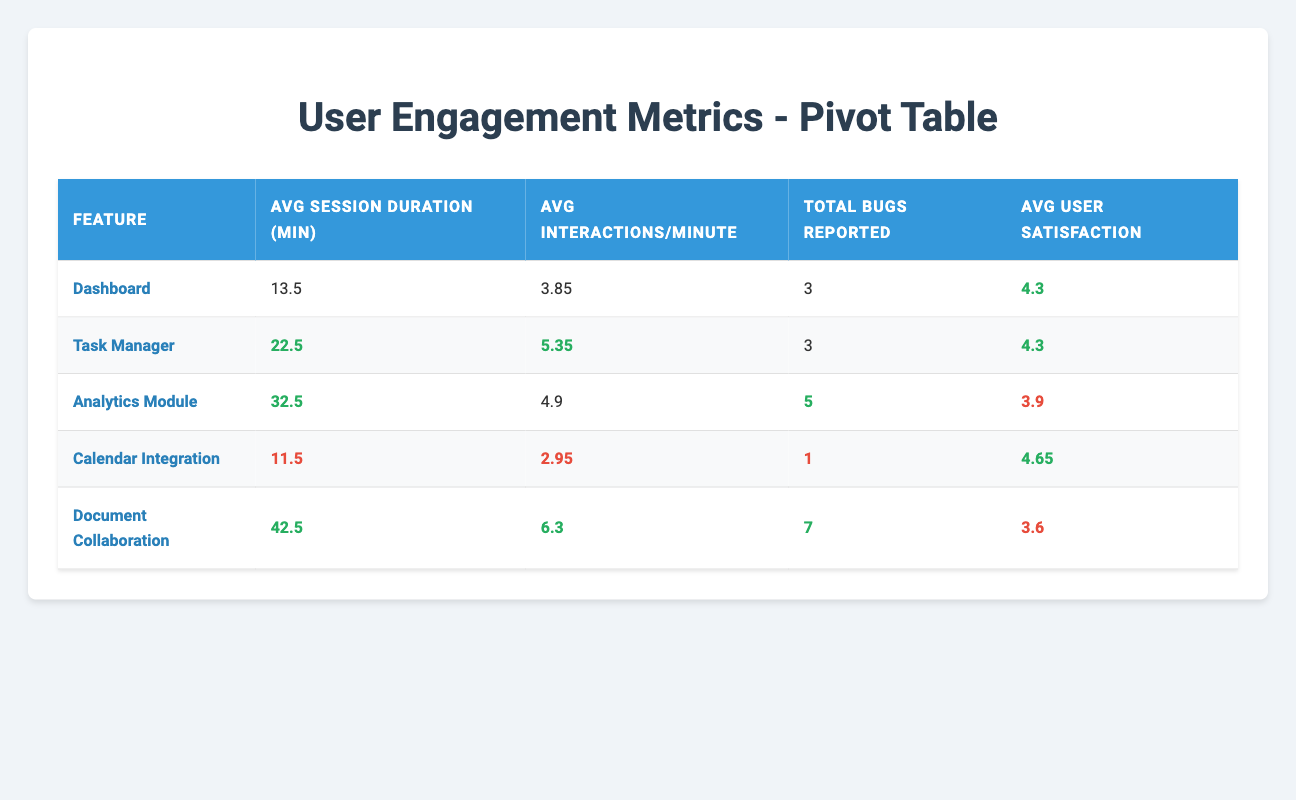What is the average session duration for the Task Manager feature? The average session duration for the Task Manager is provided directly in the table as 22.5 minutes.
Answer: 22.5 Which feature has the highest average user satisfaction score? By comparing the average user satisfaction scores in the table, Document Collaboration has the lowest score of 3.6 while Calendar Integration has the highest score of 4.65. Thus, Calendar Integration has the highest average user satisfaction score.
Answer: Calendar Integration What is the total number of bugs reported across all features? The total number of bugs can be calculated by summing the bugs reported for each feature: 3 (Dashboard) + 3 (Task Manager) + 5 (Analytics Module) + 1 (Calendar Integration) + 7 (Document Collaboration) = 19.
Answer: 19 For features with an average user satisfaction score less than 4, what is the average session duration? The features with a score less than 4 are the Analytics Module (32.5 minutes) and Document Collaboration (42.5 minutes). To find average session duration, we sum these: 32.5 + 42.5 = 75, then divide by 2: 75 / 2 = 37.5 minutes.
Answer: 37.5 Is the average interactions per minute for the Dashboard feature higher than that of Calendar Integration? The average interactions per minute for Dashboard is 3.85 and for Calendar Integration is 2.95. Since 3.85 is greater than 2.95, the answer is yes.
Answer: Yes Which feature has the highest average interactions per minute? By reviewing the interactions per minute in the table, Document Collaboration has 6.3, which is the highest among all the features listed.
Answer: Document Collaboration What is the difference in average session duration between the Analytics Module and the Dashboard? The average session duration for the Analytics Module is 32.5 minutes, and for the Dashboard, it is 13.5 minutes. The difference is calculated as 32.5 - 13.5 = 19 minutes.
Answer: 19 Which feature had the highest total bugs reported and what was that number? The total bugs reported for each feature shows that Document Collaboration has the highest total at 7 bugs reported.
Answer: Document Collaboration, 7 What is the user satisfaction score for the feature with the longest average session duration? The feature with the longest average session duration is Document Collaboration at 42.5 minutes, with a user satisfaction score of 3.6.
Answer: 3.6 